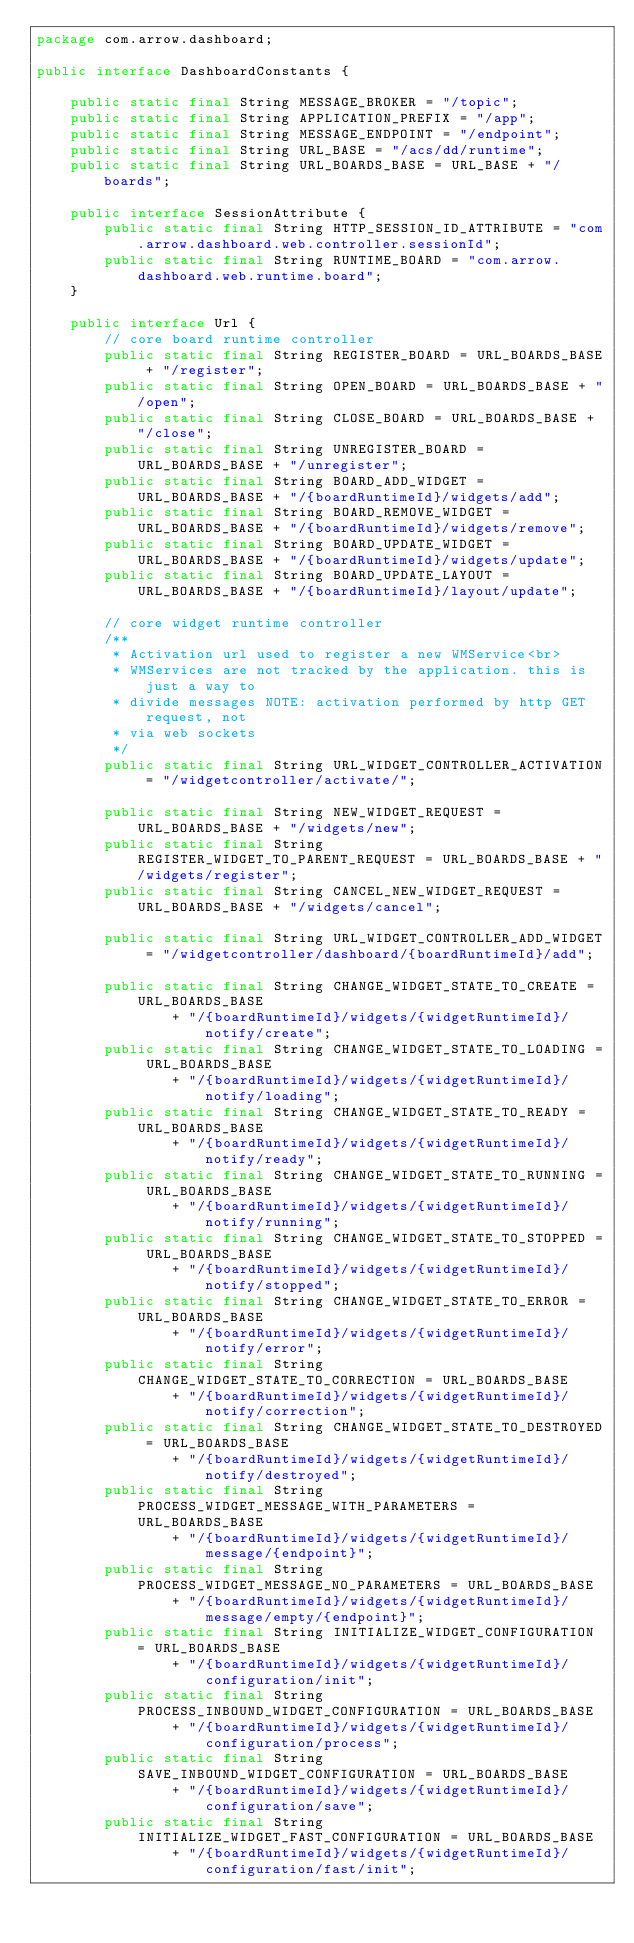<code> <loc_0><loc_0><loc_500><loc_500><_Java_>package com.arrow.dashboard;

public interface DashboardConstants {

	public static final String MESSAGE_BROKER = "/topic";
	public static final String APPLICATION_PREFIX = "/app";
	public static final String MESSAGE_ENDPOINT = "/endpoint";
	public static final String URL_BASE = "/acs/dd/runtime";
	public static final String URL_BOARDS_BASE = URL_BASE + "/boards";

	public interface SessionAttribute {
		public static final String HTTP_SESSION_ID_ATTRIBUTE = "com.arrow.dashboard.web.controller.sessionId";
		public static final String RUNTIME_BOARD = "com.arrow.dashboard.web.runtime.board";
	}

	public interface Url {
		// core board runtime controller
		public static final String REGISTER_BOARD = URL_BOARDS_BASE + "/register";
		public static final String OPEN_BOARD = URL_BOARDS_BASE + "/open";
		public static final String CLOSE_BOARD = URL_BOARDS_BASE + "/close";
		public static final String UNREGISTER_BOARD = URL_BOARDS_BASE + "/unregister";
		public static final String BOARD_ADD_WIDGET = URL_BOARDS_BASE + "/{boardRuntimeId}/widgets/add";
		public static final String BOARD_REMOVE_WIDGET = URL_BOARDS_BASE + "/{boardRuntimeId}/widgets/remove";
		public static final String BOARD_UPDATE_WIDGET = URL_BOARDS_BASE + "/{boardRuntimeId}/widgets/update";
		public static final String BOARD_UPDATE_LAYOUT = URL_BOARDS_BASE + "/{boardRuntimeId}/layout/update";

		// core widget runtime controller
		/**
		 * Activation url used to register a new WMService<br>
		 * WMServices are not tracked by the application. this is just a way to
		 * divide messages NOTE: activation performed by http GET request, not
		 * via web sockets
		 */
		public static final String URL_WIDGET_CONTROLLER_ACTIVATION = "/widgetcontroller/activate/";

		public static final String NEW_WIDGET_REQUEST = URL_BOARDS_BASE + "/widgets/new";
		public static final String REGISTER_WIDGET_TO_PARENT_REQUEST = URL_BOARDS_BASE + "/widgets/register";
		public static final String CANCEL_NEW_WIDGET_REQUEST = URL_BOARDS_BASE + "/widgets/cancel";

		public static final String URL_WIDGET_CONTROLLER_ADD_WIDGET = "/widgetcontroller/dashboard/{boardRuntimeId}/add";

		public static final String CHANGE_WIDGET_STATE_TO_CREATE = URL_BOARDS_BASE
		        + "/{boardRuntimeId}/widgets/{widgetRuntimeId}/notify/create";
		public static final String CHANGE_WIDGET_STATE_TO_LOADING = URL_BOARDS_BASE
		        + "/{boardRuntimeId}/widgets/{widgetRuntimeId}/notify/loading";
		public static final String CHANGE_WIDGET_STATE_TO_READY = URL_BOARDS_BASE
		        + "/{boardRuntimeId}/widgets/{widgetRuntimeId}/notify/ready";
		public static final String CHANGE_WIDGET_STATE_TO_RUNNING = URL_BOARDS_BASE
		        + "/{boardRuntimeId}/widgets/{widgetRuntimeId}/notify/running";
		public static final String CHANGE_WIDGET_STATE_TO_STOPPED = URL_BOARDS_BASE
		        + "/{boardRuntimeId}/widgets/{widgetRuntimeId}/notify/stopped";
		public static final String CHANGE_WIDGET_STATE_TO_ERROR = URL_BOARDS_BASE
		        + "/{boardRuntimeId}/widgets/{widgetRuntimeId}/notify/error";
		public static final String CHANGE_WIDGET_STATE_TO_CORRECTION = URL_BOARDS_BASE
		        + "/{boardRuntimeId}/widgets/{widgetRuntimeId}/notify/correction";
		public static final String CHANGE_WIDGET_STATE_TO_DESTROYED = URL_BOARDS_BASE
		        + "/{boardRuntimeId}/widgets/{widgetRuntimeId}/notify/destroyed";
		public static final String PROCESS_WIDGET_MESSAGE_WITH_PARAMETERS = URL_BOARDS_BASE
		        + "/{boardRuntimeId}/widgets/{widgetRuntimeId}/message/{endpoint}";
		public static final String PROCESS_WIDGET_MESSAGE_NO_PARAMETERS = URL_BOARDS_BASE
		        + "/{boardRuntimeId}/widgets/{widgetRuntimeId}/message/empty/{endpoint}";
		public static final String INITIALIZE_WIDGET_CONFIGURATION = URL_BOARDS_BASE
		        + "/{boardRuntimeId}/widgets/{widgetRuntimeId}/configuration/init";
		public static final String PROCESS_INBOUND_WIDGET_CONFIGURATION = URL_BOARDS_BASE
		        + "/{boardRuntimeId}/widgets/{widgetRuntimeId}/configuration/process";
		public static final String SAVE_INBOUND_WIDGET_CONFIGURATION = URL_BOARDS_BASE
		        + "/{boardRuntimeId}/widgets/{widgetRuntimeId}/configuration/save";
		public static final String INITIALIZE_WIDGET_FAST_CONFIGURATION = URL_BOARDS_BASE
		        + "/{boardRuntimeId}/widgets/{widgetRuntimeId}/configuration/fast/init";</code> 